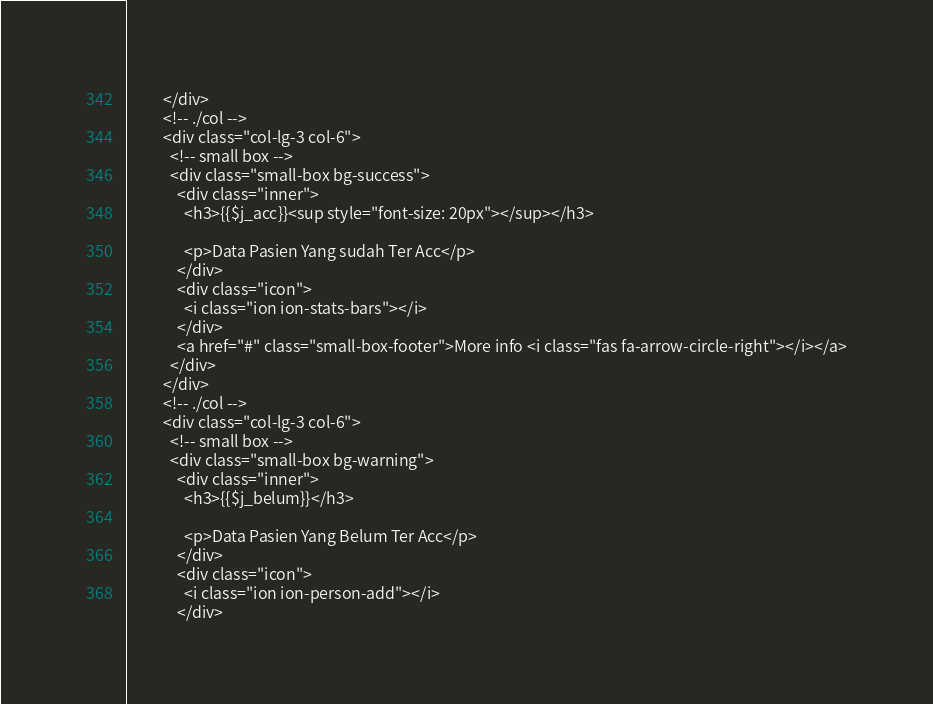Convert code to text. <code><loc_0><loc_0><loc_500><loc_500><_PHP_>          </div>
          <!-- ./col -->
          <div class="col-lg-3 col-6">
            <!-- small box -->
            <div class="small-box bg-success">
              <div class="inner">
                <h3>{{$j_acc}}<sup style="font-size: 20px"></sup></h3>

                <p>Data Pasien Yang sudah Ter Acc</p>
              </div>
              <div class="icon">
                <i class="ion ion-stats-bars"></i>
              </div>
              <a href="#" class="small-box-footer">More info <i class="fas fa-arrow-circle-right"></i></a>
            </div>
          </div>
          <!-- ./col -->
          <div class="col-lg-3 col-6">
            <!-- small box -->
            <div class="small-box bg-warning">
              <div class="inner">
                <h3>{{$j_belum}}</h3>

                <p>Data Pasien Yang Belum Ter Acc</p>
              </div>
              <div class="icon">
                <i class="ion ion-person-add"></i>
              </div></code> 